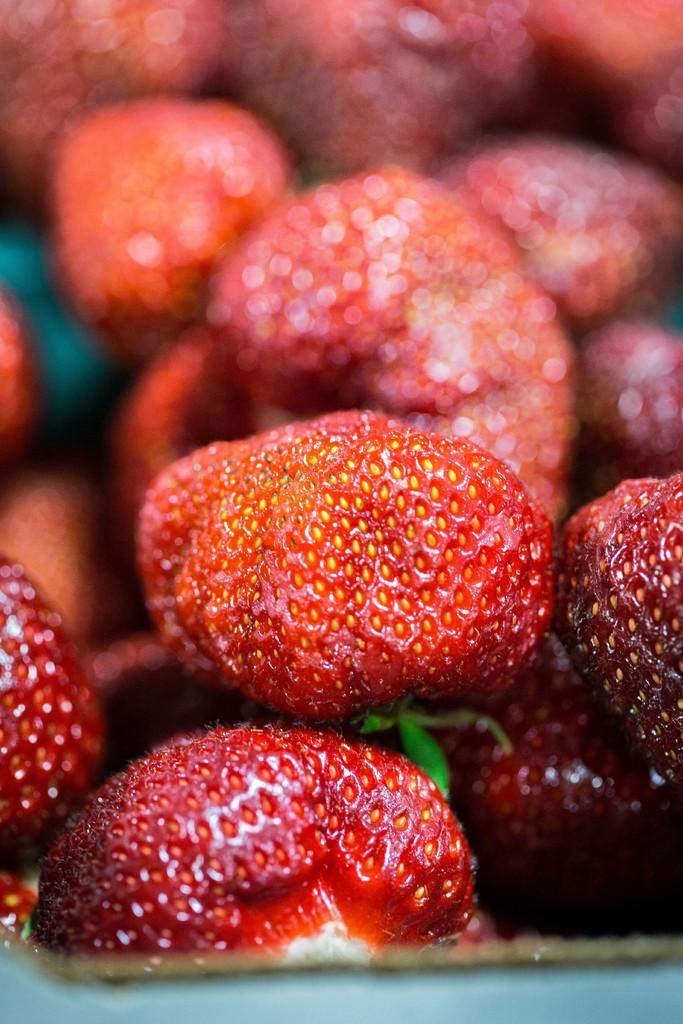Please provide a concise description of this image. It is a zoomed in picture of strawberries. 